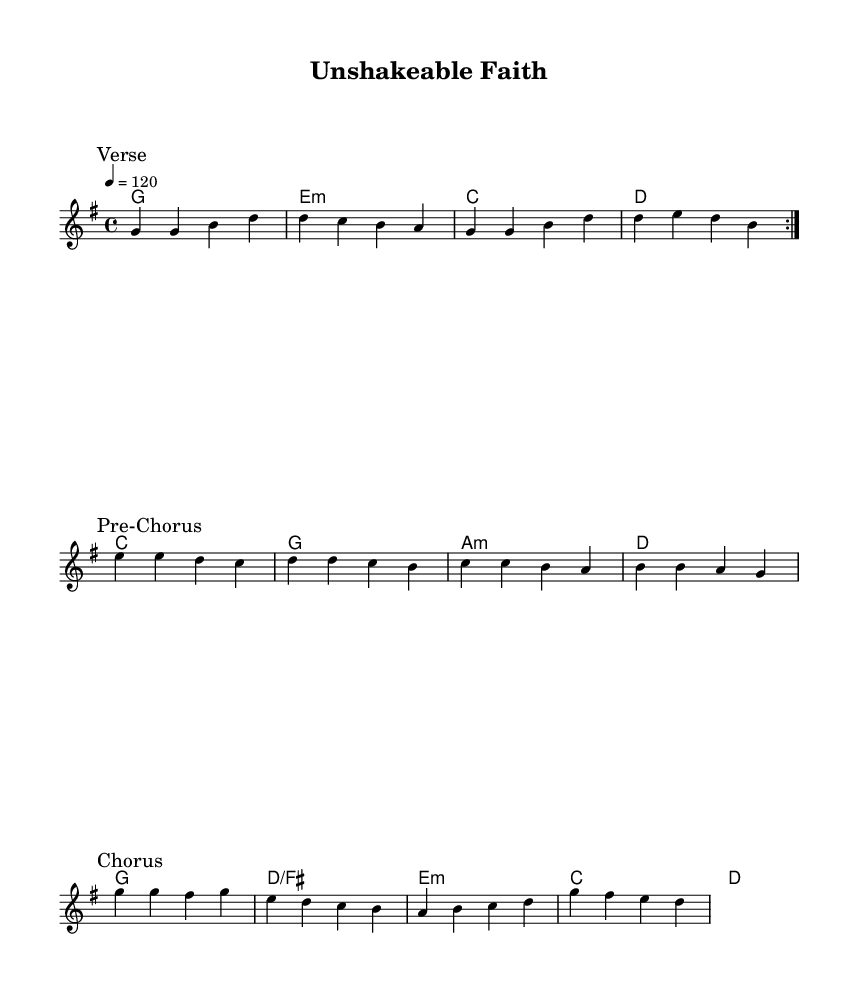What is the key signature of this music? The key signature is G major, which has one sharp indicated by the presence of an F# note.
Answer: G major What is the time signature of this piece? The time signature is 4/4, which means there are four beats per measure. This can be inferred from the notation at the beginning of the score.
Answer: 4/4 What is the tempo marking for this composition? The tempo marking is a quarter note equals 120 beats per minute, which is explicitly stated in the score.
Answer: 120 How many sections are present in this piece? There are three distinct sections: Verse, Pre-Chorus, and Chorus, indicated by their respective markings in the music.
Answer: Three What is the first chord in the verse? The first chord in the verse is G major, as indicated in the harmonies section of the score.
Answer: G In what way is the melody structured in the verse? The melody in the verse is structured with a repeating pattern that consists of eight measures, as indicated by the repeat sign.
Answer: Repeating pattern Which chord follows the chorus? The chord that follows the chorus is D major, as indicated in the harmonies section right after the chorus concludes.
Answer: D 